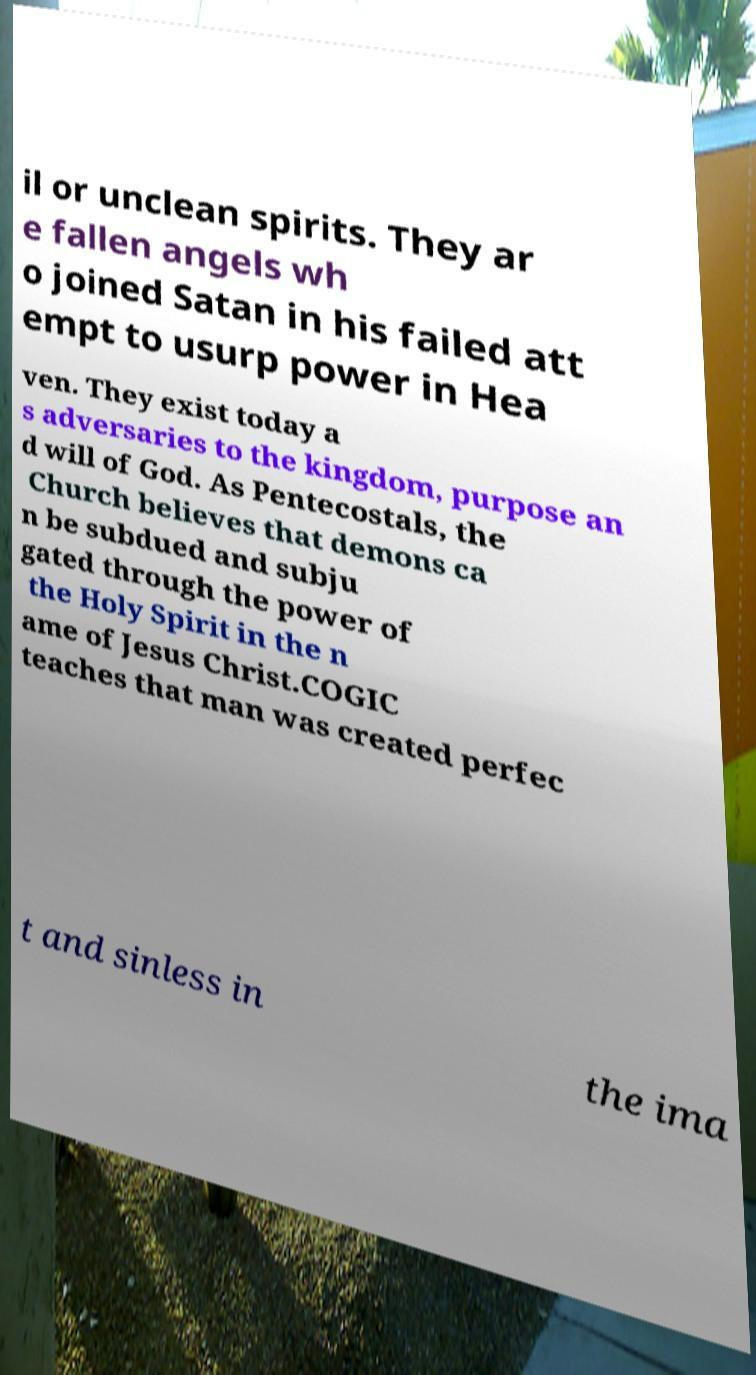There's text embedded in this image that I need extracted. Can you transcribe it verbatim? il or unclean spirits. They ar e fallen angels wh o joined Satan in his failed att empt to usurp power in Hea ven. They exist today a s adversaries to the kingdom, purpose an d will of God. As Pentecostals, the Church believes that demons ca n be subdued and subju gated through the power of the Holy Spirit in the n ame of Jesus Christ.COGIC teaches that man was created perfec t and sinless in the ima 